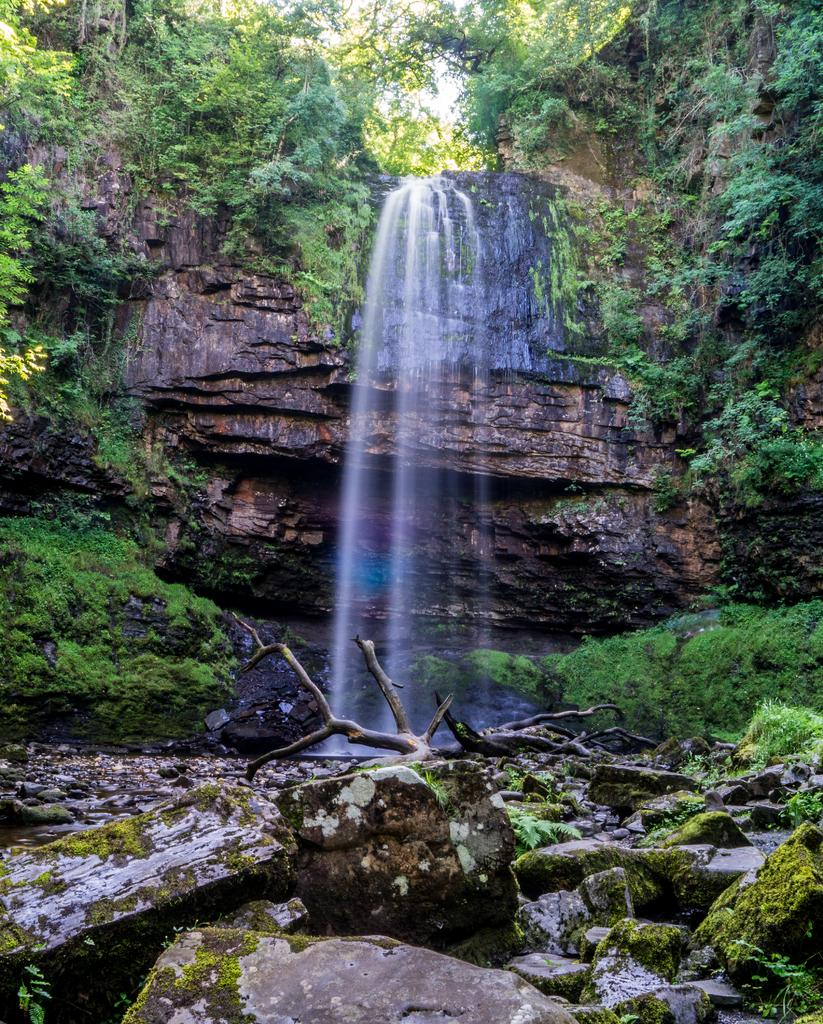What is the main feature in the center of the image? There is a waterfall in the center of the image. What types of vegetation can be seen on the right side of the image? There are plants and trees on the right side of the image. What other objects are present on the right side of the image? There are rocks on the right side of the image. What types of vegetation can be seen on the left side of the image? There are plants on the left side of the image. What other objects are present on the left side of the image? There are trees and rocks on the left side of the image. What arithmetic problem can be solved using the rocks in the image? There is no arithmetic problem present in the image, as it features a waterfall, plants, trees, and rocks. 